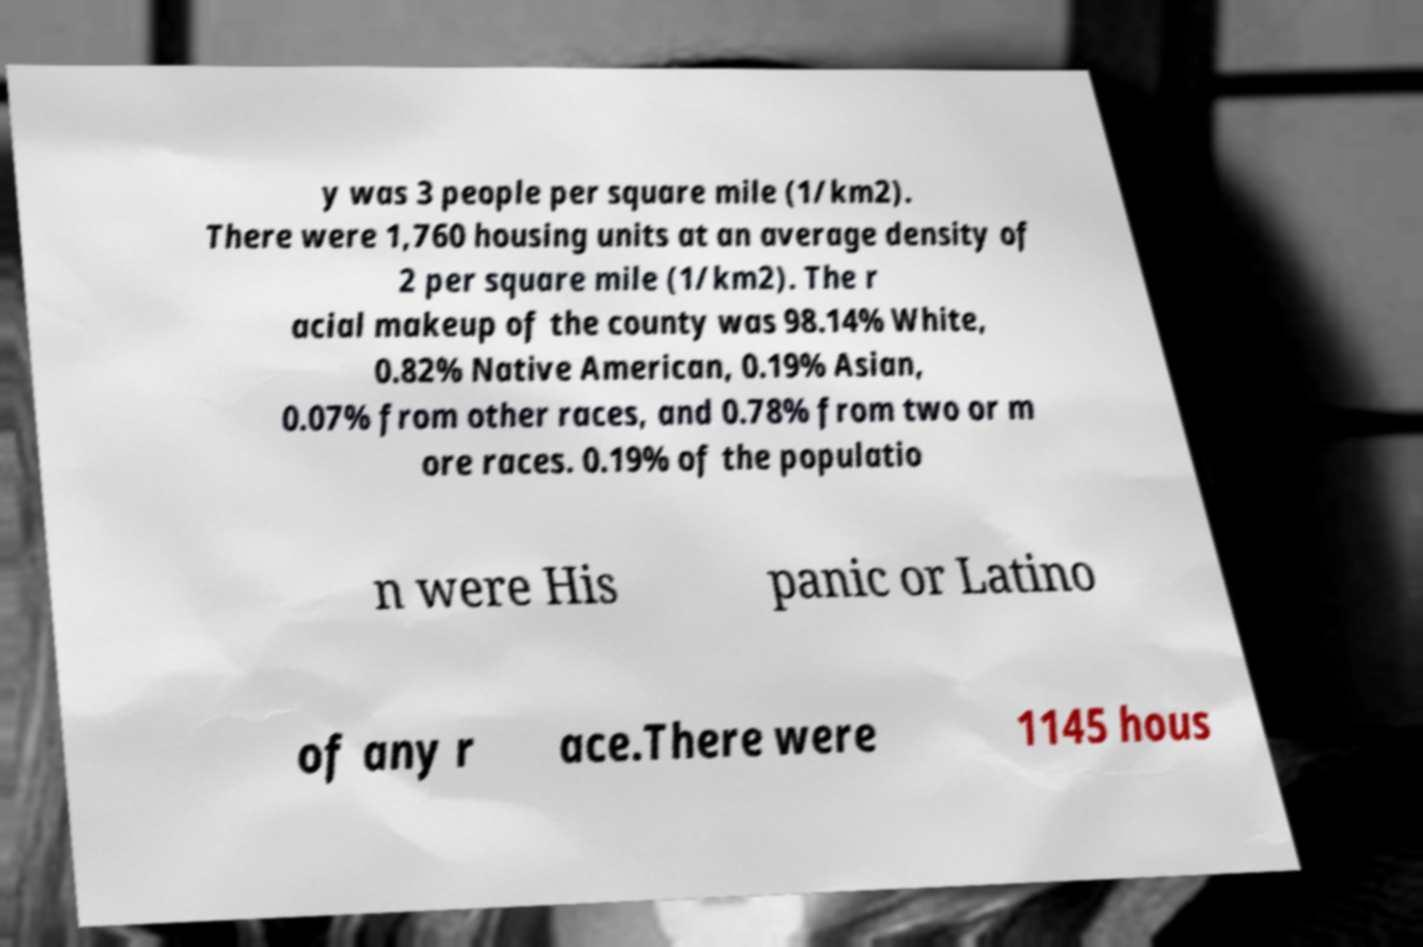What messages or text are displayed in this image? I need them in a readable, typed format. y was 3 people per square mile (1/km2). There were 1,760 housing units at an average density of 2 per square mile (1/km2). The r acial makeup of the county was 98.14% White, 0.82% Native American, 0.19% Asian, 0.07% from other races, and 0.78% from two or m ore races. 0.19% of the populatio n were His panic or Latino of any r ace.There were 1145 hous 